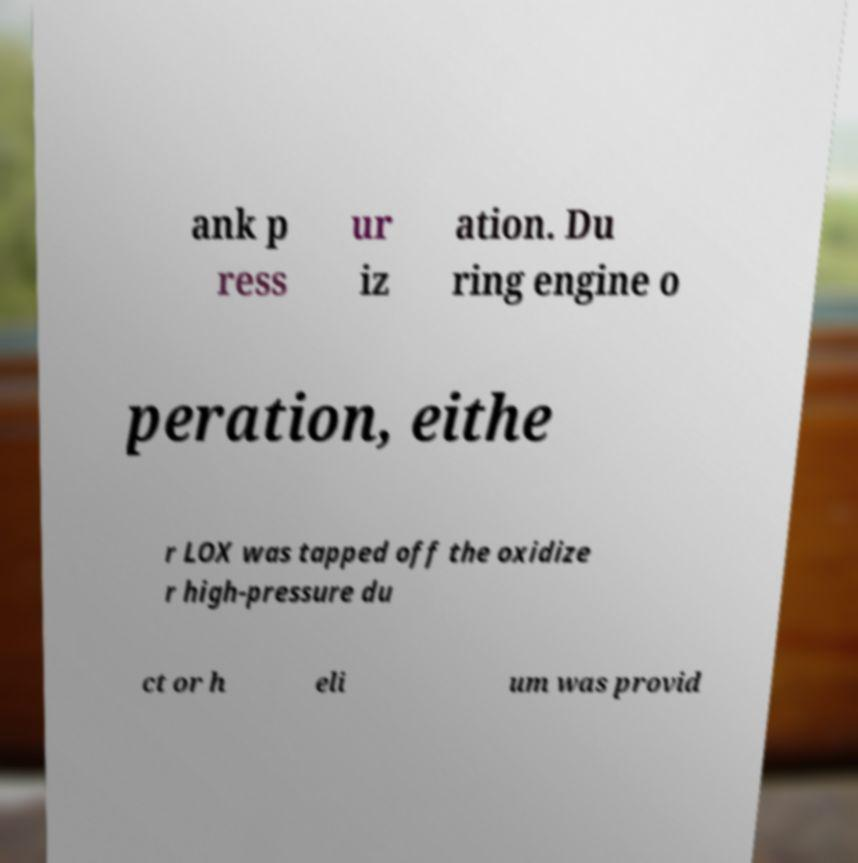Please identify and transcribe the text found in this image. ank p ress ur iz ation. Du ring engine o peration, eithe r LOX was tapped off the oxidize r high-pressure du ct or h eli um was provid 